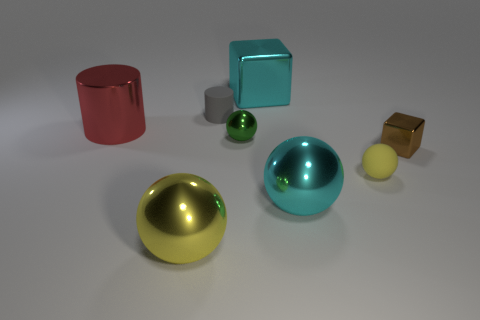Add 1 small brown shiny objects. How many objects exist? 9 Subtract all cylinders. How many objects are left? 6 Subtract all big red things. Subtract all small brown shiny objects. How many objects are left? 6 Add 4 red metallic objects. How many red metallic objects are left? 5 Add 7 cyan shiny things. How many cyan shiny things exist? 9 Subtract 0 gray spheres. How many objects are left? 8 